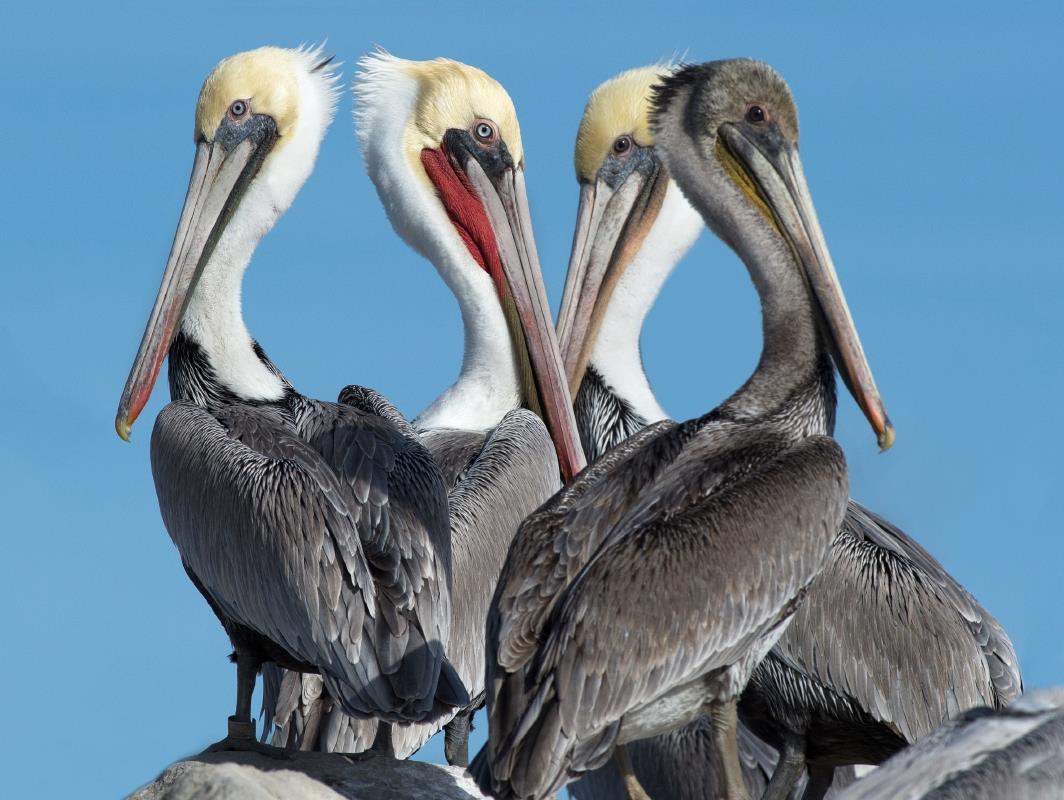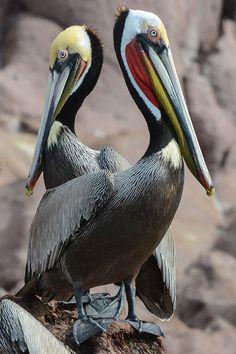The first image is the image on the left, the second image is the image on the right. Evaluate the accuracy of this statement regarding the images: "Two birds are perched on a post in one of the images.". Is it true? Answer yes or no. No. The first image is the image on the left, the second image is the image on the right. Analyze the images presented: Is the assertion "An image shows only two birds, which are overlapped facing each other so their heads and necks form a heart shape." valid? Answer yes or no. No. 